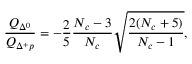<formula> <loc_0><loc_0><loc_500><loc_500>\frac { Q _ { \Delta ^ { 0 } } } { Q _ { \Delta ^ { + } p } } = - \frac { 2 } { 5 } \frac { N _ { c } - 3 } { N _ { c } } \sqrt { \frac { 2 ( N _ { c } + 5 ) } { N _ { c } - 1 } } ,</formula> 